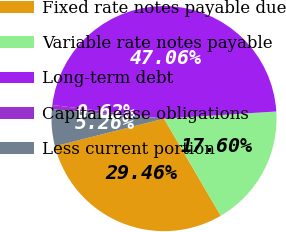<chart> <loc_0><loc_0><loc_500><loc_500><pie_chart><fcel>Fixed rate notes payable due<fcel>Variable rate notes payable<fcel>Long-term debt<fcel>Capital lease obligations<fcel>Less current portion<nl><fcel>29.46%<fcel>17.6%<fcel>47.06%<fcel>0.62%<fcel>5.26%<nl></chart> 